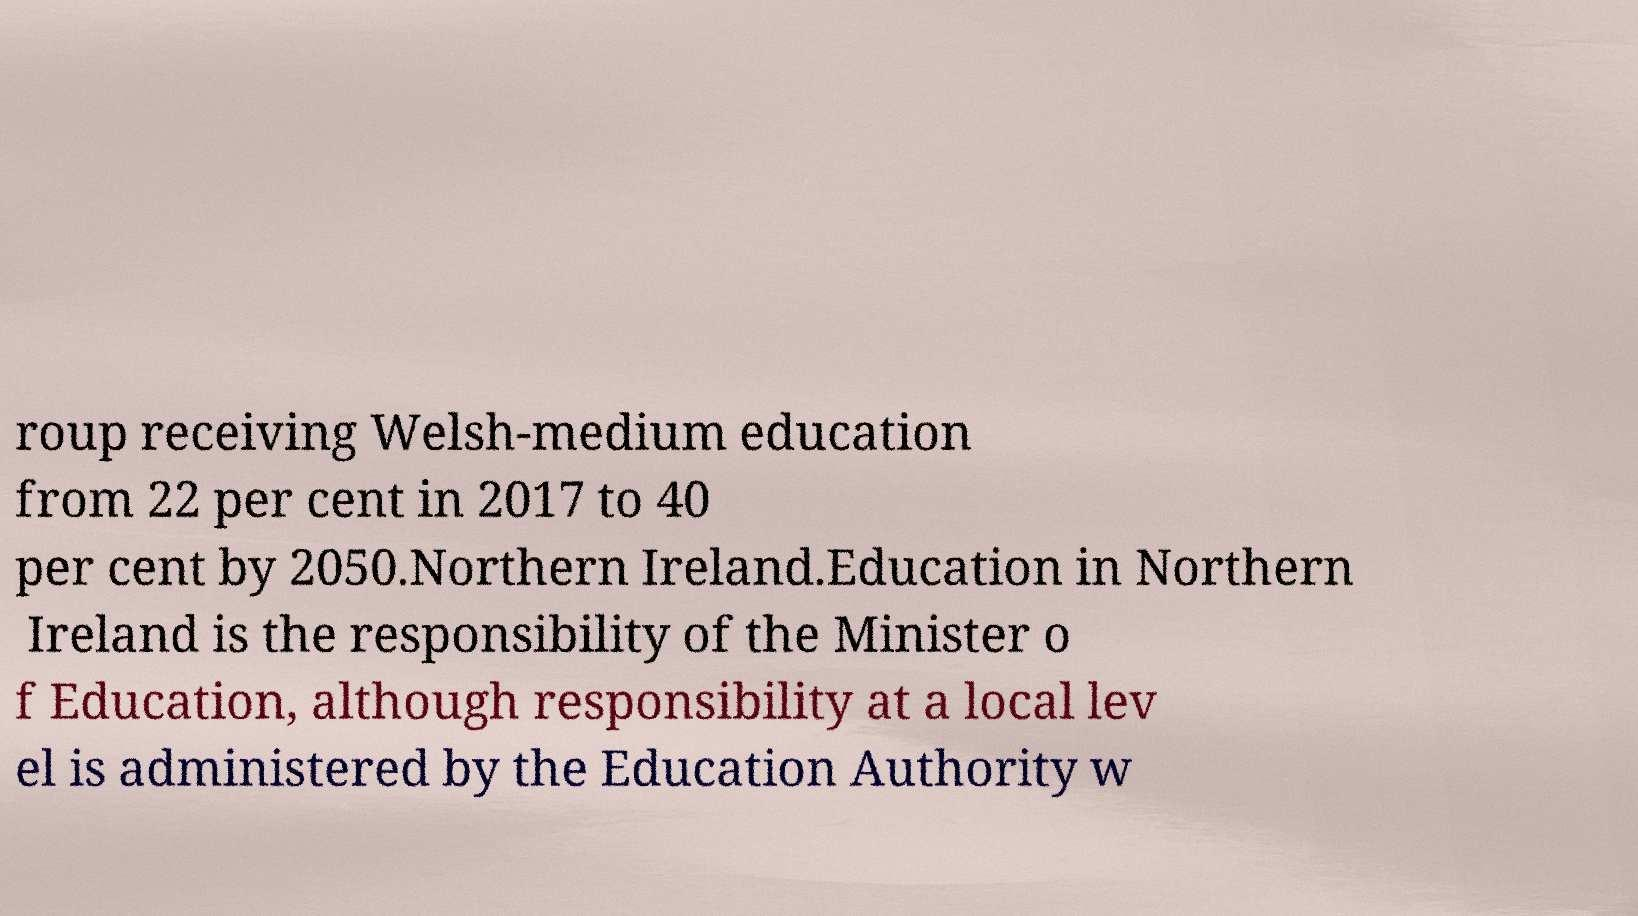Could you extract and type out the text from this image? roup receiving Welsh-medium education from 22 per cent in 2017 to 40 per cent by 2050.Northern Ireland.Education in Northern Ireland is the responsibility of the Minister o f Education, although responsibility at a local lev el is administered by the Education Authority w 